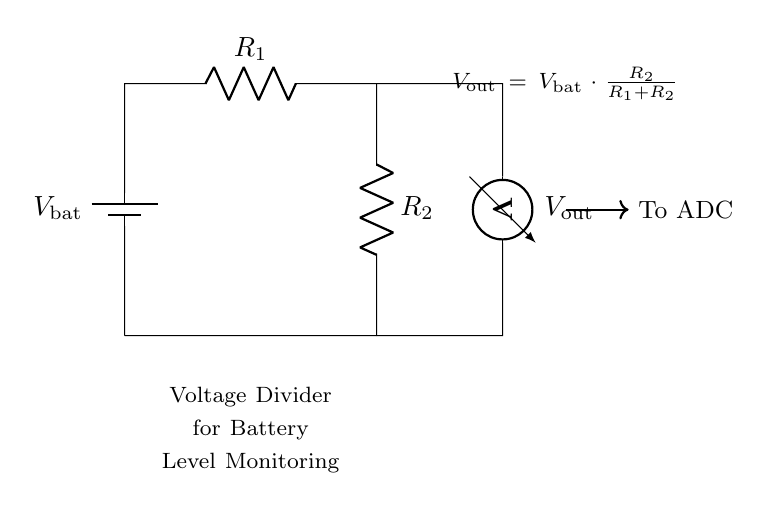What is the purpose of the components labeled R1 and R2? R1 and R2 form a voltage divider, allowing the output voltage to be a fraction of the battery voltage based on their resistance values.
Answer: Voltage divider What is the output voltage formula indicated in the diagram? The output voltage is calculated using the formula Vout = Vbat * (R2 / (R1 + R2)), which determines how much of the battery voltage appears across R2.
Answer: Vout = Vbat * (R2 / (R1 + R2)) How many resistors are present in the circuit? The diagram shows two resistors, R1 and R2, which are part of the voltage divider for measuring battery levels.
Answer: Two What is the function of the voltmeter in this circuit? The voltmeter measures the output voltage Vout across R2, providing a reading of the battery's voltage level based on the voltage divider principle.
Answer: Measurement If R1 is much larger than R2, what happens to Vout? If R1 is significantly larger than R2, the output voltage Vout approaches zero, meaning very little voltage is dropped across R2 compared to Vbat.
Answer: Approaches zero How does this circuit relate to battery level monitoring? This voltage divider circuit is designed to provide a scaled-down voltage that can be safely monitored by an Analog to Digital Converter (ADC), allowing for accurate battery level readings.
Answer: Battery level monitoring What is the significance of the arrow pointing to the ADC? The arrow indicates that the output voltage Vout is being sent to an Analog to Digital Converter (ADC) for digital processing, necessary for monitoring and evaluating the battery levels accurately.
Answer: ADC processing 